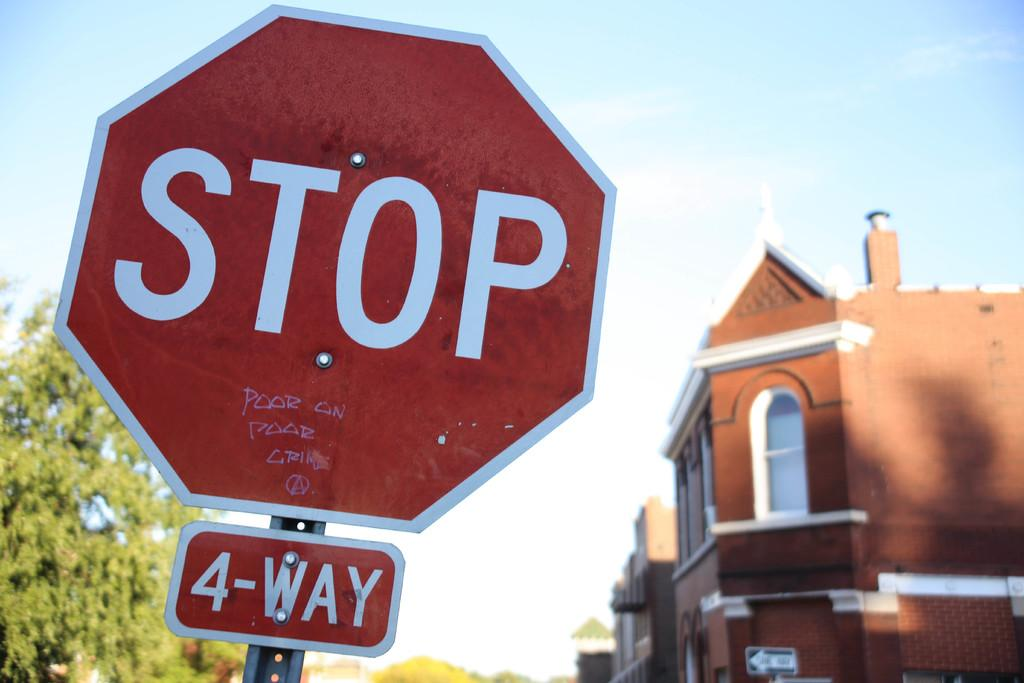<image>
Share a concise interpretation of the image provided. A large and red Stop sign in front of a house. 